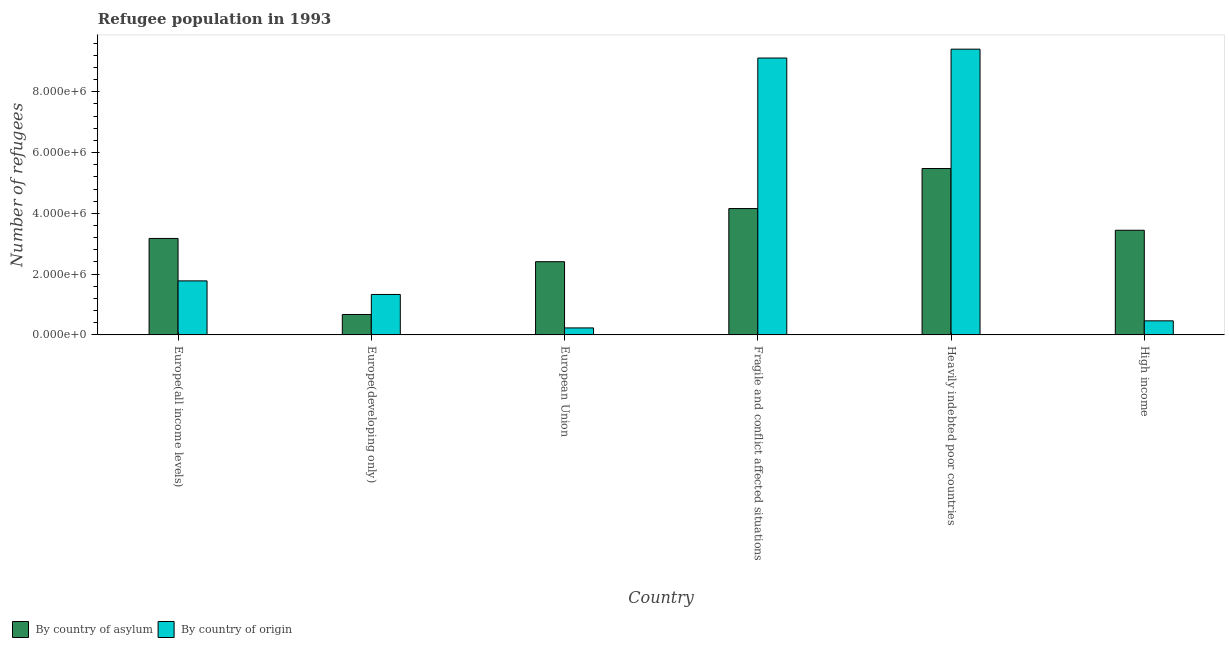How many different coloured bars are there?
Provide a succinct answer. 2. How many groups of bars are there?
Provide a succinct answer. 6. How many bars are there on the 4th tick from the right?
Give a very brief answer. 2. What is the label of the 3rd group of bars from the left?
Offer a terse response. European Union. In how many cases, is the number of bars for a given country not equal to the number of legend labels?
Give a very brief answer. 0. What is the number of refugees by country of asylum in Europe(all income levels)?
Your answer should be compact. 3.18e+06. Across all countries, what is the maximum number of refugees by country of asylum?
Your answer should be compact. 5.48e+06. Across all countries, what is the minimum number of refugees by country of origin?
Ensure brevity in your answer.  2.30e+05. In which country was the number of refugees by country of asylum maximum?
Give a very brief answer. Heavily indebted poor countries. In which country was the number of refugees by country of asylum minimum?
Give a very brief answer. Europe(developing only). What is the total number of refugees by country of asylum in the graph?
Your answer should be compact. 1.93e+07. What is the difference between the number of refugees by country of origin in Europe(all income levels) and that in European Union?
Provide a short and direct response. 1.55e+06. What is the difference between the number of refugees by country of asylum in European Union and the number of refugees by country of origin in Europe(developing only)?
Offer a very short reply. 1.08e+06. What is the average number of refugees by country of asylum per country?
Your answer should be very brief. 3.22e+06. What is the difference between the number of refugees by country of asylum and number of refugees by country of origin in Fragile and conflict affected situations?
Offer a terse response. -4.95e+06. In how many countries, is the number of refugees by country of origin greater than 3600000 ?
Offer a very short reply. 2. What is the ratio of the number of refugees by country of asylum in Europe(all income levels) to that in Europe(developing only)?
Provide a succinct answer. 4.72. Is the number of refugees by country of asylum in European Union less than that in High income?
Give a very brief answer. Yes. Is the difference between the number of refugees by country of asylum in European Union and High income greater than the difference between the number of refugees by country of origin in European Union and High income?
Ensure brevity in your answer.  No. What is the difference between the highest and the second highest number of refugees by country of asylum?
Give a very brief answer. 1.32e+06. What is the difference between the highest and the lowest number of refugees by country of asylum?
Give a very brief answer. 4.80e+06. What does the 1st bar from the left in European Union represents?
Your answer should be very brief. By country of asylum. What does the 2nd bar from the right in Europe(all income levels) represents?
Keep it short and to the point. By country of asylum. How many bars are there?
Provide a succinct answer. 12. How many countries are there in the graph?
Provide a succinct answer. 6. Does the graph contain any zero values?
Your response must be concise. No. Does the graph contain grids?
Make the answer very short. No. Where does the legend appear in the graph?
Ensure brevity in your answer.  Bottom left. How many legend labels are there?
Ensure brevity in your answer.  2. What is the title of the graph?
Give a very brief answer. Refugee population in 1993. What is the label or title of the X-axis?
Offer a very short reply. Country. What is the label or title of the Y-axis?
Make the answer very short. Number of refugees. What is the Number of refugees of By country of asylum in Europe(all income levels)?
Give a very brief answer. 3.18e+06. What is the Number of refugees in By country of origin in Europe(all income levels)?
Give a very brief answer. 1.78e+06. What is the Number of refugees of By country of asylum in Europe(developing only)?
Your answer should be very brief. 6.72e+05. What is the Number of refugees in By country of origin in Europe(developing only)?
Provide a short and direct response. 1.33e+06. What is the Number of refugees of By country of asylum in European Union?
Provide a succinct answer. 2.41e+06. What is the Number of refugees of By country of origin in European Union?
Ensure brevity in your answer.  2.30e+05. What is the Number of refugees in By country of asylum in Fragile and conflict affected situations?
Your answer should be compact. 4.16e+06. What is the Number of refugees in By country of origin in Fragile and conflict affected situations?
Your answer should be very brief. 9.11e+06. What is the Number of refugees of By country of asylum in Heavily indebted poor countries?
Give a very brief answer. 5.48e+06. What is the Number of refugees of By country of origin in Heavily indebted poor countries?
Your response must be concise. 9.40e+06. What is the Number of refugees of By country of asylum in High income?
Ensure brevity in your answer.  3.44e+06. What is the Number of refugees in By country of origin in High income?
Your answer should be compact. 4.63e+05. Across all countries, what is the maximum Number of refugees of By country of asylum?
Give a very brief answer. 5.48e+06. Across all countries, what is the maximum Number of refugees in By country of origin?
Offer a very short reply. 9.40e+06. Across all countries, what is the minimum Number of refugees in By country of asylum?
Provide a short and direct response. 6.72e+05. Across all countries, what is the minimum Number of refugees of By country of origin?
Ensure brevity in your answer.  2.30e+05. What is the total Number of refugees in By country of asylum in the graph?
Your answer should be very brief. 1.93e+07. What is the total Number of refugees of By country of origin in the graph?
Your response must be concise. 2.23e+07. What is the difference between the Number of refugees in By country of asylum in Europe(all income levels) and that in Europe(developing only)?
Your answer should be compact. 2.50e+06. What is the difference between the Number of refugees of By country of origin in Europe(all income levels) and that in Europe(developing only)?
Provide a short and direct response. 4.47e+05. What is the difference between the Number of refugees in By country of asylum in Europe(all income levels) and that in European Union?
Ensure brevity in your answer.  7.65e+05. What is the difference between the Number of refugees in By country of origin in Europe(all income levels) and that in European Union?
Your answer should be very brief. 1.55e+06. What is the difference between the Number of refugees of By country of asylum in Europe(all income levels) and that in Fragile and conflict affected situations?
Offer a very short reply. -9.83e+05. What is the difference between the Number of refugees of By country of origin in Europe(all income levels) and that in Fragile and conflict affected situations?
Your answer should be very brief. -7.33e+06. What is the difference between the Number of refugees of By country of asylum in Europe(all income levels) and that in Heavily indebted poor countries?
Keep it short and to the point. -2.30e+06. What is the difference between the Number of refugees of By country of origin in Europe(all income levels) and that in Heavily indebted poor countries?
Your answer should be compact. -7.63e+06. What is the difference between the Number of refugees in By country of asylum in Europe(all income levels) and that in High income?
Offer a very short reply. -2.69e+05. What is the difference between the Number of refugees of By country of origin in Europe(all income levels) and that in High income?
Make the answer very short. 1.31e+06. What is the difference between the Number of refugees in By country of asylum in Europe(developing only) and that in European Union?
Offer a terse response. -1.74e+06. What is the difference between the Number of refugees in By country of origin in Europe(developing only) and that in European Union?
Offer a very short reply. 1.10e+06. What is the difference between the Number of refugees in By country of asylum in Europe(developing only) and that in Fragile and conflict affected situations?
Ensure brevity in your answer.  -3.49e+06. What is the difference between the Number of refugees in By country of origin in Europe(developing only) and that in Fragile and conflict affected situations?
Provide a short and direct response. -7.78e+06. What is the difference between the Number of refugees of By country of asylum in Europe(developing only) and that in Heavily indebted poor countries?
Your response must be concise. -4.80e+06. What is the difference between the Number of refugees of By country of origin in Europe(developing only) and that in Heavily indebted poor countries?
Offer a very short reply. -8.07e+06. What is the difference between the Number of refugees of By country of asylum in Europe(developing only) and that in High income?
Offer a terse response. -2.77e+06. What is the difference between the Number of refugees in By country of origin in Europe(developing only) and that in High income?
Your response must be concise. 8.68e+05. What is the difference between the Number of refugees in By country of asylum in European Union and that in Fragile and conflict affected situations?
Keep it short and to the point. -1.75e+06. What is the difference between the Number of refugees in By country of origin in European Union and that in Fragile and conflict affected situations?
Make the answer very short. -8.88e+06. What is the difference between the Number of refugees of By country of asylum in European Union and that in Heavily indebted poor countries?
Offer a very short reply. -3.07e+06. What is the difference between the Number of refugees in By country of origin in European Union and that in Heavily indebted poor countries?
Your answer should be compact. -9.17e+06. What is the difference between the Number of refugees of By country of asylum in European Union and that in High income?
Provide a succinct answer. -1.03e+06. What is the difference between the Number of refugees in By country of origin in European Union and that in High income?
Provide a short and direct response. -2.33e+05. What is the difference between the Number of refugees of By country of asylum in Fragile and conflict affected situations and that in Heavily indebted poor countries?
Ensure brevity in your answer.  -1.32e+06. What is the difference between the Number of refugees of By country of origin in Fragile and conflict affected situations and that in Heavily indebted poor countries?
Keep it short and to the point. -2.92e+05. What is the difference between the Number of refugees in By country of asylum in Fragile and conflict affected situations and that in High income?
Offer a very short reply. 7.14e+05. What is the difference between the Number of refugees in By country of origin in Fragile and conflict affected situations and that in High income?
Ensure brevity in your answer.  8.65e+06. What is the difference between the Number of refugees of By country of asylum in Heavily indebted poor countries and that in High income?
Ensure brevity in your answer.  2.03e+06. What is the difference between the Number of refugees in By country of origin in Heavily indebted poor countries and that in High income?
Give a very brief answer. 8.94e+06. What is the difference between the Number of refugees of By country of asylum in Europe(all income levels) and the Number of refugees of By country of origin in Europe(developing only)?
Your response must be concise. 1.84e+06. What is the difference between the Number of refugees in By country of asylum in Europe(all income levels) and the Number of refugees in By country of origin in European Union?
Your response must be concise. 2.94e+06. What is the difference between the Number of refugees in By country of asylum in Europe(all income levels) and the Number of refugees in By country of origin in Fragile and conflict affected situations?
Make the answer very short. -5.94e+06. What is the difference between the Number of refugees in By country of asylum in Europe(all income levels) and the Number of refugees in By country of origin in Heavily indebted poor countries?
Keep it short and to the point. -6.23e+06. What is the difference between the Number of refugees in By country of asylum in Europe(all income levels) and the Number of refugees in By country of origin in High income?
Make the answer very short. 2.71e+06. What is the difference between the Number of refugees in By country of asylum in Europe(developing only) and the Number of refugees in By country of origin in European Union?
Make the answer very short. 4.42e+05. What is the difference between the Number of refugees in By country of asylum in Europe(developing only) and the Number of refugees in By country of origin in Fragile and conflict affected situations?
Ensure brevity in your answer.  -8.44e+06. What is the difference between the Number of refugees of By country of asylum in Europe(developing only) and the Number of refugees of By country of origin in Heavily indebted poor countries?
Offer a very short reply. -8.73e+06. What is the difference between the Number of refugees in By country of asylum in Europe(developing only) and the Number of refugees in By country of origin in High income?
Provide a short and direct response. 2.09e+05. What is the difference between the Number of refugees in By country of asylum in European Union and the Number of refugees in By country of origin in Fragile and conflict affected situations?
Give a very brief answer. -6.70e+06. What is the difference between the Number of refugees of By country of asylum in European Union and the Number of refugees of By country of origin in Heavily indebted poor countries?
Your response must be concise. -6.99e+06. What is the difference between the Number of refugees of By country of asylum in European Union and the Number of refugees of By country of origin in High income?
Make the answer very short. 1.95e+06. What is the difference between the Number of refugees in By country of asylum in Fragile and conflict affected situations and the Number of refugees in By country of origin in Heavily indebted poor countries?
Provide a succinct answer. -5.25e+06. What is the difference between the Number of refugees in By country of asylum in Fragile and conflict affected situations and the Number of refugees in By country of origin in High income?
Your answer should be very brief. 3.70e+06. What is the difference between the Number of refugees of By country of asylum in Heavily indebted poor countries and the Number of refugees of By country of origin in High income?
Ensure brevity in your answer.  5.01e+06. What is the average Number of refugees of By country of asylum per country?
Keep it short and to the point. 3.22e+06. What is the average Number of refugees in By country of origin per country?
Your answer should be very brief. 3.72e+06. What is the difference between the Number of refugees of By country of asylum and Number of refugees of By country of origin in Europe(all income levels)?
Provide a succinct answer. 1.40e+06. What is the difference between the Number of refugees of By country of asylum and Number of refugees of By country of origin in Europe(developing only)?
Give a very brief answer. -6.59e+05. What is the difference between the Number of refugees in By country of asylum and Number of refugees in By country of origin in European Union?
Provide a succinct answer. 2.18e+06. What is the difference between the Number of refugees in By country of asylum and Number of refugees in By country of origin in Fragile and conflict affected situations?
Your response must be concise. -4.95e+06. What is the difference between the Number of refugees of By country of asylum and Number of refugees of By country of origin in Heavily indebted poor countries?
Your response must be concise. -3.93e+06. What is the difference between the Number of refugees of By country of asylum and Number of refugees of By country of origin in High income?
Provide a short and direct response. 2.98e+06. What is the ratio of the Number of refugees in By country of asylum in Europe(all income levels) to that in Europe(developing only)?
Make the answer very short. 4.72. What is the ratio of the Number of refugees in By country of origin in Europe(all income levels) to that in Europe(developing only)?
Make the answer very short. 1.34. What is the ratio of the Number of refugees in By country of asylum in Europe(all income levels) to that in European Union?
Keep it short and to the point. 1.32. What is the ratio of the Number of refugees of By country of origin in Europe(all income levels) to that in European Union?
Offer a terse response. 7.72. What is the ratio of the Number of refugees in By country of asylum in Europe(all income levels) to that in Fragile and conflict affected situations?
Offer a terse response. 0.76. What is the ratio of the Number of refugees of By country of origin in Europe(all income levels) to that in Fragile and conflict affected situations?
Offer a terse response. 0.2. What is the ratio of the Number of refugees of By country of asylum in Europe(all income levels) to that in Heavily indebted poor countries?
Offer a very short reply. 0.58. What is the ratio of the Number of refugees of By country of origin in Europe(all income levels) to that in Heavily indebted poor countries?
Your answer should be compact. 0.19. What is the ratio of the Number of refugees of By country of asylum in Europe(all income levels) to that in High income?
Offer a terse response. 0.92. What is the ratio of the Number of refugees in By country of origin in Europe(all income levels) to that in High income?
Provide a succinct answer. 3.84. What is the ratio of the Number of refugees in By country of asylum in Europe(developing only) to that in European Union?
Your answer should be compact. 0.28. What is the ratio of the Number of refugees of By country of origin in Europe(developing only) to that in European Union?
Ensure brevity in your answer.  5.78. What is the ratio of the Number of refugees in By country of asylum in Europe(developing only) to that in Fragile and conflict affected situations?
Provide a succinct answer. 0.16. What is the ratio of the Number of refugees in By country of origin in Europe(developing only) to that in Fragile and conflict affected situations?
Provide a succinct answer. 0.15. What is the ratio of the Number of refugees of By country of asylum in Europe(developing only) to that in Heavily indebted poor countries?
Ensure brevity in your answer.  0.12. What is the ratio of the Number of refugees of By country of origin in Europe(developing only) to that in Heavily indebted poor countries?
Keep it short and to the point. 0.14. What is the ratio of the Number of refugees in By country of asylum in Europe(developing only) to that in High income?
Keep it short and to the point. 0.2. What is the ratio of the Number of refugees of By country of origin in Europe(developing only) to that in High income?
Offer a terse response. 2.87. What is the ratio of the Number of refugees of By country of asylum in European Union to that in Fragile and conflict affected situations?
Offer a terse response. 0.58. What is the ratio of the Number of refugees in By country of origin in European Union to that in Fragile and conflict affected situations?
Keep it short and to the point. 0.03. What is the ratio of the Number of refugees in By country of asylum in European Union to that in Heavily indebted poor countries?
Provide a short and direct response. 0.44. What is the ratio of the Number of refugees in By country of origin in European Union to that in Heavily indebted poor countries?
Provide a short and direct response. 0.02. What is the ratio of the Number of refugees in By country of asylum in European Union to that in High income?
Your response must be concise. 0.7. What is the ratio of the Number of refugees of By country of origin in European Union to that in High income?
Offer a terse response. 0.5. What is the ratio of the Number of refugees of By country of asylum in Fragile and conflict affected situations to that in Heavily indebted poor countries?
Give a very brief answer. 0.76. What is the ratio of the Number of refugees of By country of origin in Fragile and conflict affected situations to that in Heavily indebted poor countries?
Offer a very short reply. 0.97. What is the ratio of the Number of refugees in By country of asylum in Fragile and conflict affected situations to that in High income?
Keep it short and to the point. 1.21. What is the ratio of the Number of refugees of By country of origin in Fragile and conflict affected situations to that in High income?
Make the answer very short. 19.67. What is the ratio of the Number of refugees of By country of asylum in Heavily indebted poor countries to that in High income?
Provide a succinct answer. 1.59. What is the ratio of the Number of refugees in By country of origin in Heavily indebted poor countries to that in High income?
Offer a very short reply. 20.3. What is the difference between the highest and the second highest Number of refugees in By country of asylum?
Ensure brevity in your answer.  1.32e+06. What is the difference between the highest and the second highest Number of refugees in By country of origin?
Your response must be concise. 2.92e+05. What is the difference between the highest and the lowest Number of refugees of By country of asylum?
Make the answer very short. 4.80e+06. What is the difference between the highest and the lowest Number of refugees of By country of origin?
Offer a terse response. 9.17e+06. 